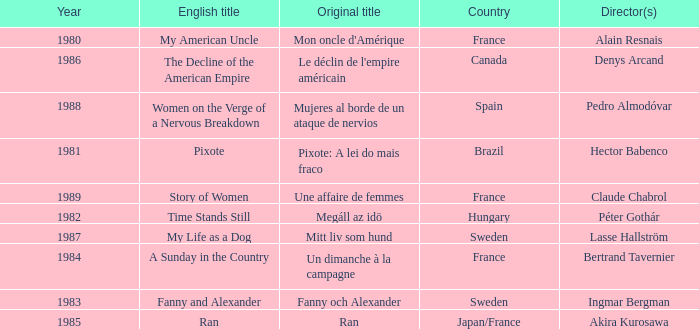What was the year of Megáll az Idö? 1982.0. 